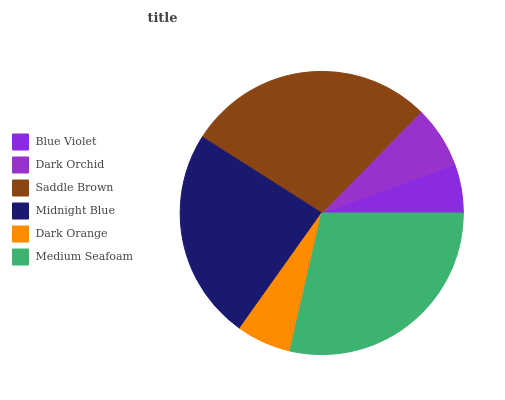Is Blue Violet the minimum?
Answer yes or no. Yes. Is Medium Seafoam the maximum?
Answer yes or no. Yes. Is Dark Orchid the minimum?
Answer yes or no. No. Is Dark Orchid the maximum?
Answer yes or no. No. Is Dark Orchid greater than Blue Violet?
Answer yes or no. Yes. Is Blue Violet less than Dark Orchid?
Answer yes or no. Yes. Is Blue Violet greater than Dark Orchid?
Answer yes or no. No. Is Dark Orchid less than Blue Violet?
Answer yes or no. No. Is Midnight Blue the high median?
Answer yes or no. Yes. Is Dark Orchid the low median?
Answer yes or no. Yes. Is Blue Violet the high median?
Answer yes or no. No. Is Blue Violet the low median?
Answer yes or no. No. 